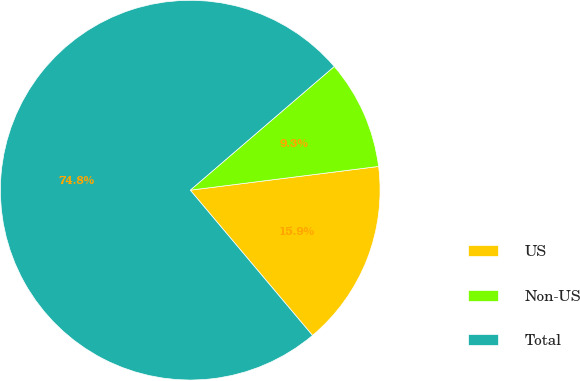Convert chart. <chart><loc_0><loc_0><loc_500><loc_500><pie_chart><fcel>US<fcel>Non-US<fcel>Total<nl><fcel>15.86%<fcel>9.3%<fcel>74.84%<nl></chart> 